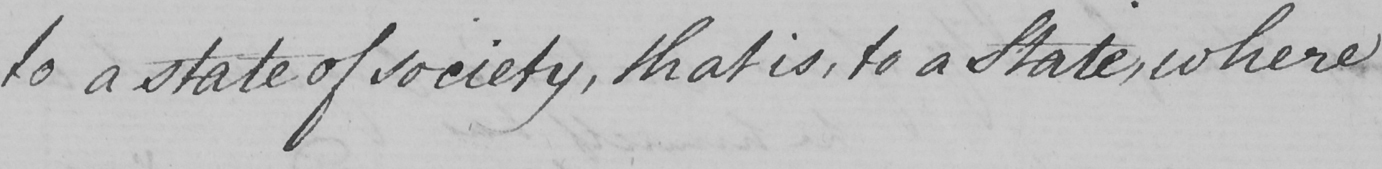What text is written in this handwritten line? to a state of society , that is , to a State , where 